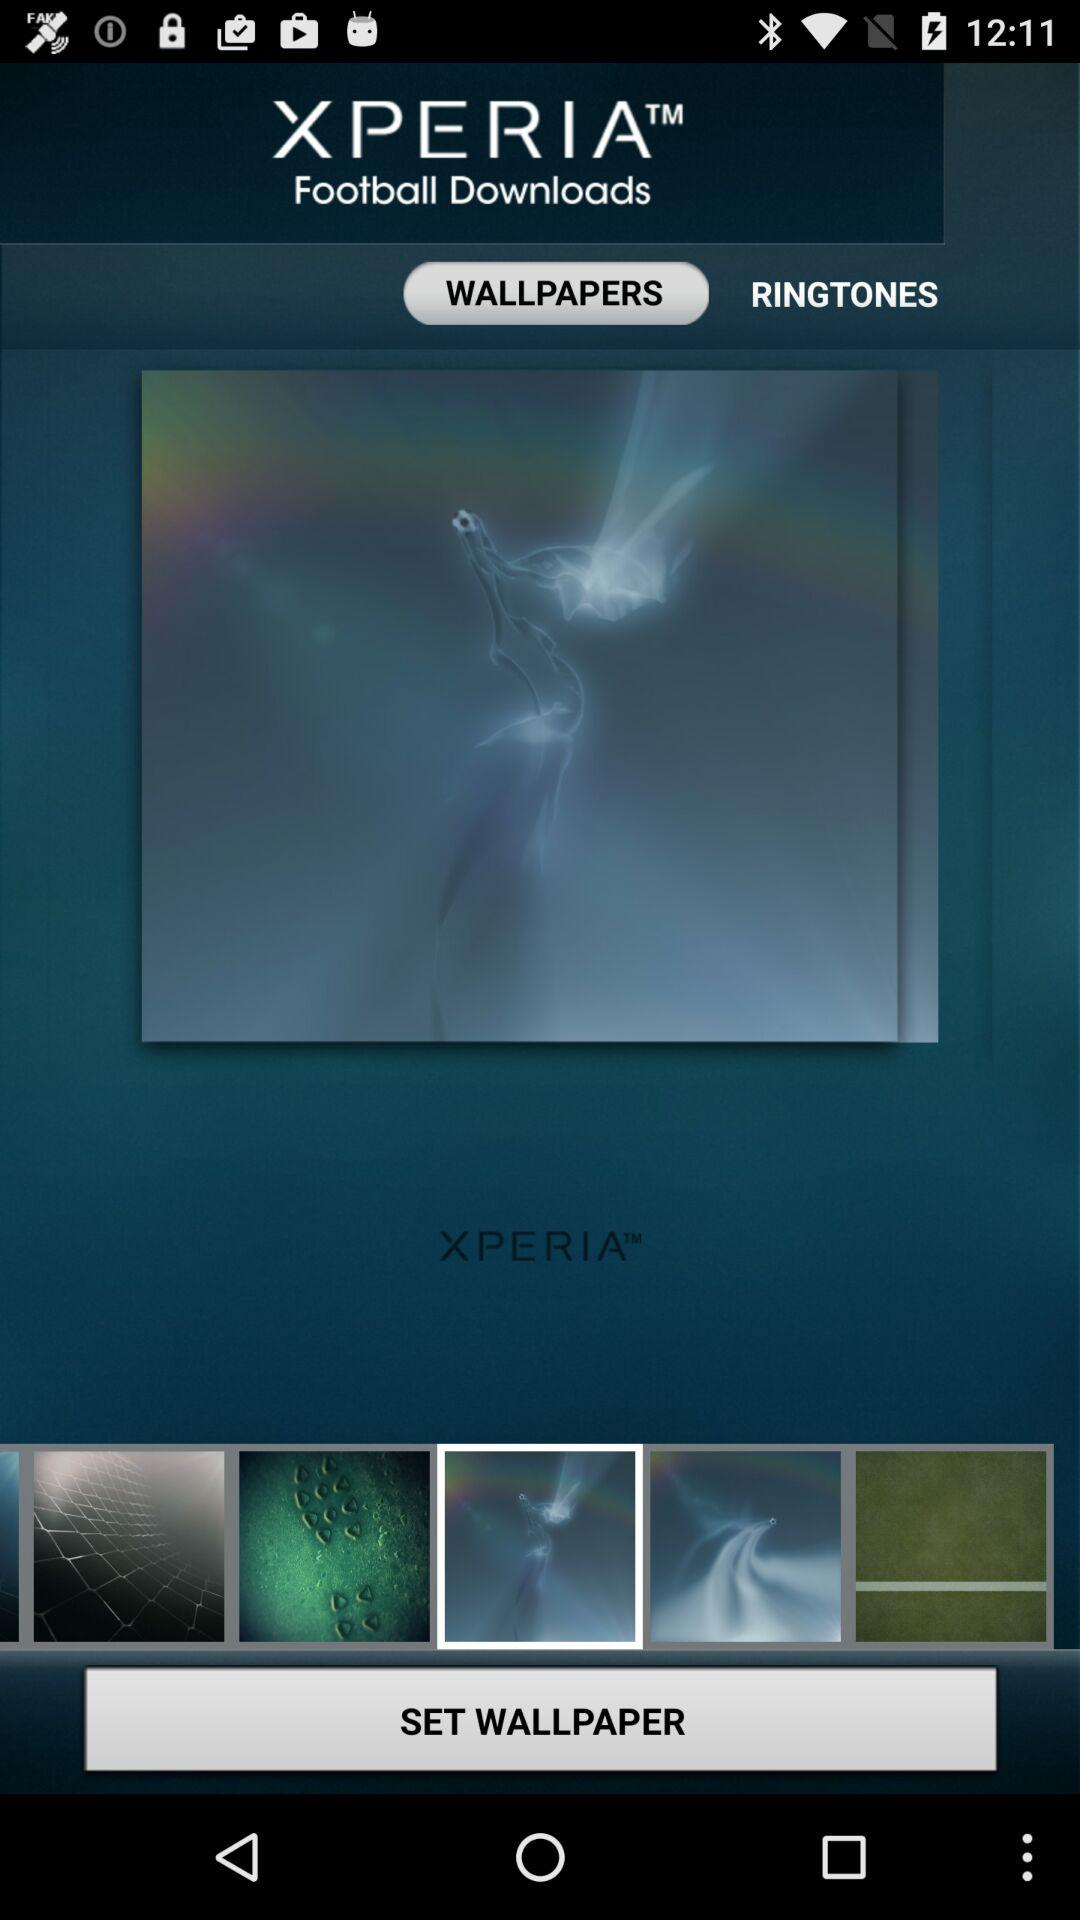How many ringtones are there?
When the provided information is insufficient, respond with <no answer>. <no answer> 